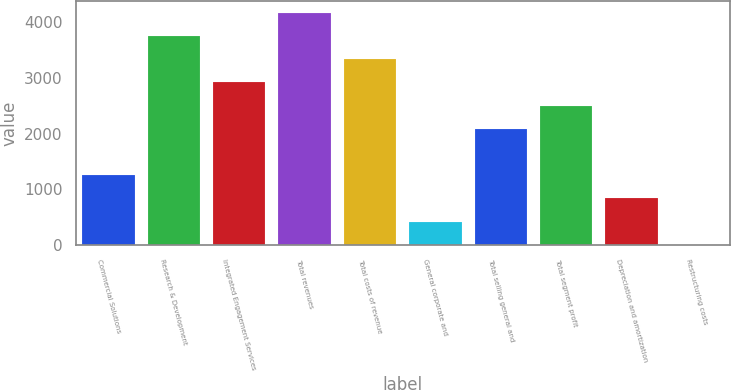Convert chart. <chart><loc_0><loc_0><loc_500><loc_500><bar_chart><fcel>Commercial Solutions<fcel>Research & Development<fcel>Integrated Engagement Services<fcel>Total revenues<fcel>Total costs of revenue<fcel>General corporate and<fcel>Total selling general and<fcel>Total segment profit<fcel>Depreciation and amortization<fcel>Restructuring costs<nl><fcel>1255.8<fcel>3749.4<fcel>2918.2<fcel>4165<fcel>3333.8<fcel>424.6<fcel>2087<fcel>2502.6<fcel>840.2<fcel>9<nl></chart> 